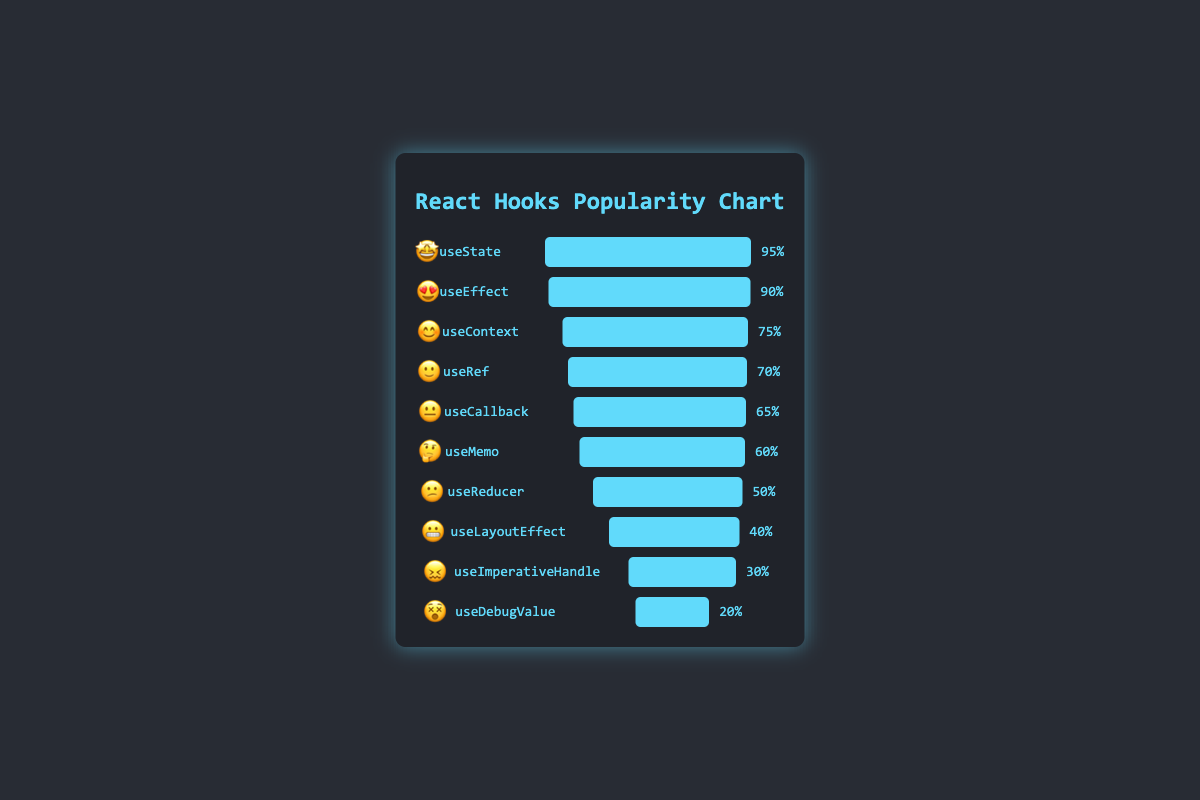What is the highest rated React hook based on the chart? The highest rated React hook is "useState" with a popularity of 95%. This is visually represented by the longest bar and an emoji face with star eyes (🤩).
Answer: useState What is the difference in popularity between "useState" and "useEffect"? "useState" has a popularity of 95%, while "useEffect" has 90%. The difference is 95 - 90 = 5%.
Answer: 5% Which hook has the lowest popularity? The hook with the lowest popularity is "useDebugValue" with a 20% popularity rate. This is represented by the shortest bar and an emoji face with x eyes (😵).
Answer: useDebugValue How many hooks have a popularity rating of 70% or higher? The hooks with a popularity rating of 70% or higher are "useState" (95%), "useEffect" (90%), "useContext" (75%), and "useRef" (70%). There are a total of 4 such hooks.
Answer: 4 Which hook has a smiley face (😊) emoji associated with it? The hook with a smiley face emoji (😊) is "useContext". This can be identified visually by locating the smiley face emoji.
Answer: useContext What is the combined popularity of "useCallback" and "useMemo"? The popularity of "useCallback" is 65%, and "useMemo" is 60%. Combined, their popularity is 65 + 60 = 125%.
Answer: 125% Is "useLayoutEffect" more or less popular than "useReducer"? "useLayoutEffect" has a popularity of 40%, while "useReducer" has 50%. "useLayoutEffect" is less popular.
Answer: less What is the average popularity of all the hooks shown in the chart? Sum the popularity values: 95 + 90 + 75 + 70 + 65 + 60 + 50 + 40 + 30 + 20 = 595. There are 10 hooks. The average is 595 / 10 = 59.5%.
Answer: 59.5% Which hooks have a popularity less than 50%? The hooks with a popularity of less than 50% are "useLayoutEffect" (40%), "useImperativeHandle" (30%), and "useDebugValue" (20%).
Answer: useLayoutEffect, useImperativeHandle, useDebugValue Which emoji represents the "useRef" hook? The "useRef" hook is represented by the slightly smiling face emoji (🙂). This can be visually identified by finding the bar labeled "useRef".
Answer: 🙂 